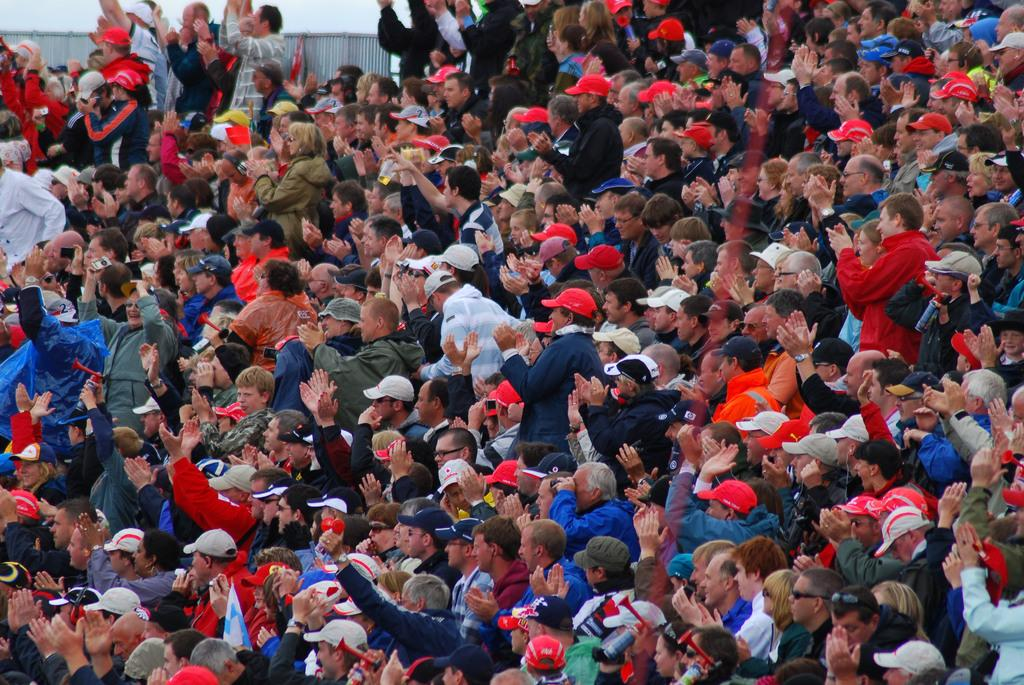What is the main subject of the image? The main subject of the image is a large crowd. What can be observed about the clothing of the people in the crowd? Many people in the crowd are wearing red caps. What can be seen in the background of the image? There appears to be a fencing in the background of the image. How many cracks can be seen in the red caps in the image? There are no cracks visible on the red caps in the image, as the caps appear to be in good condition. 